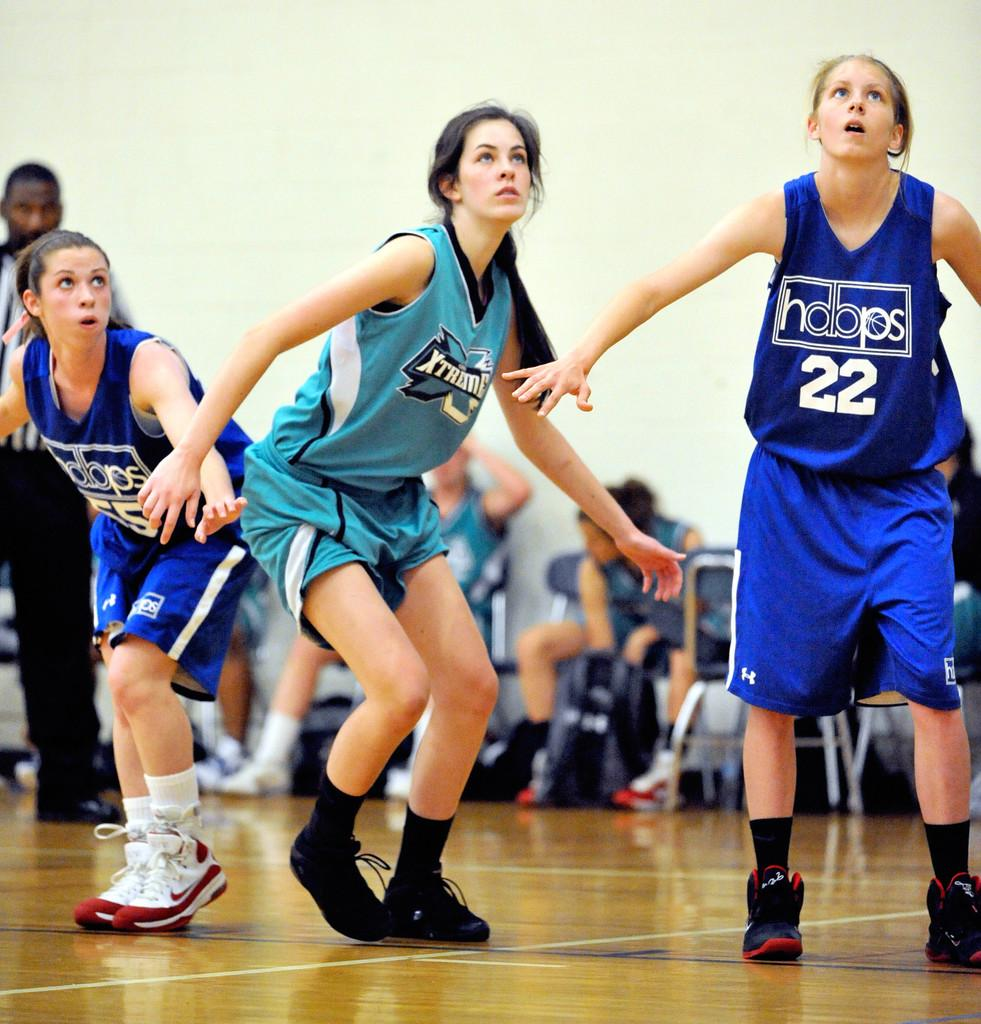<image>
Create a compact narrative representing the image presented. A team of female players wear uniforms for hdbps. 